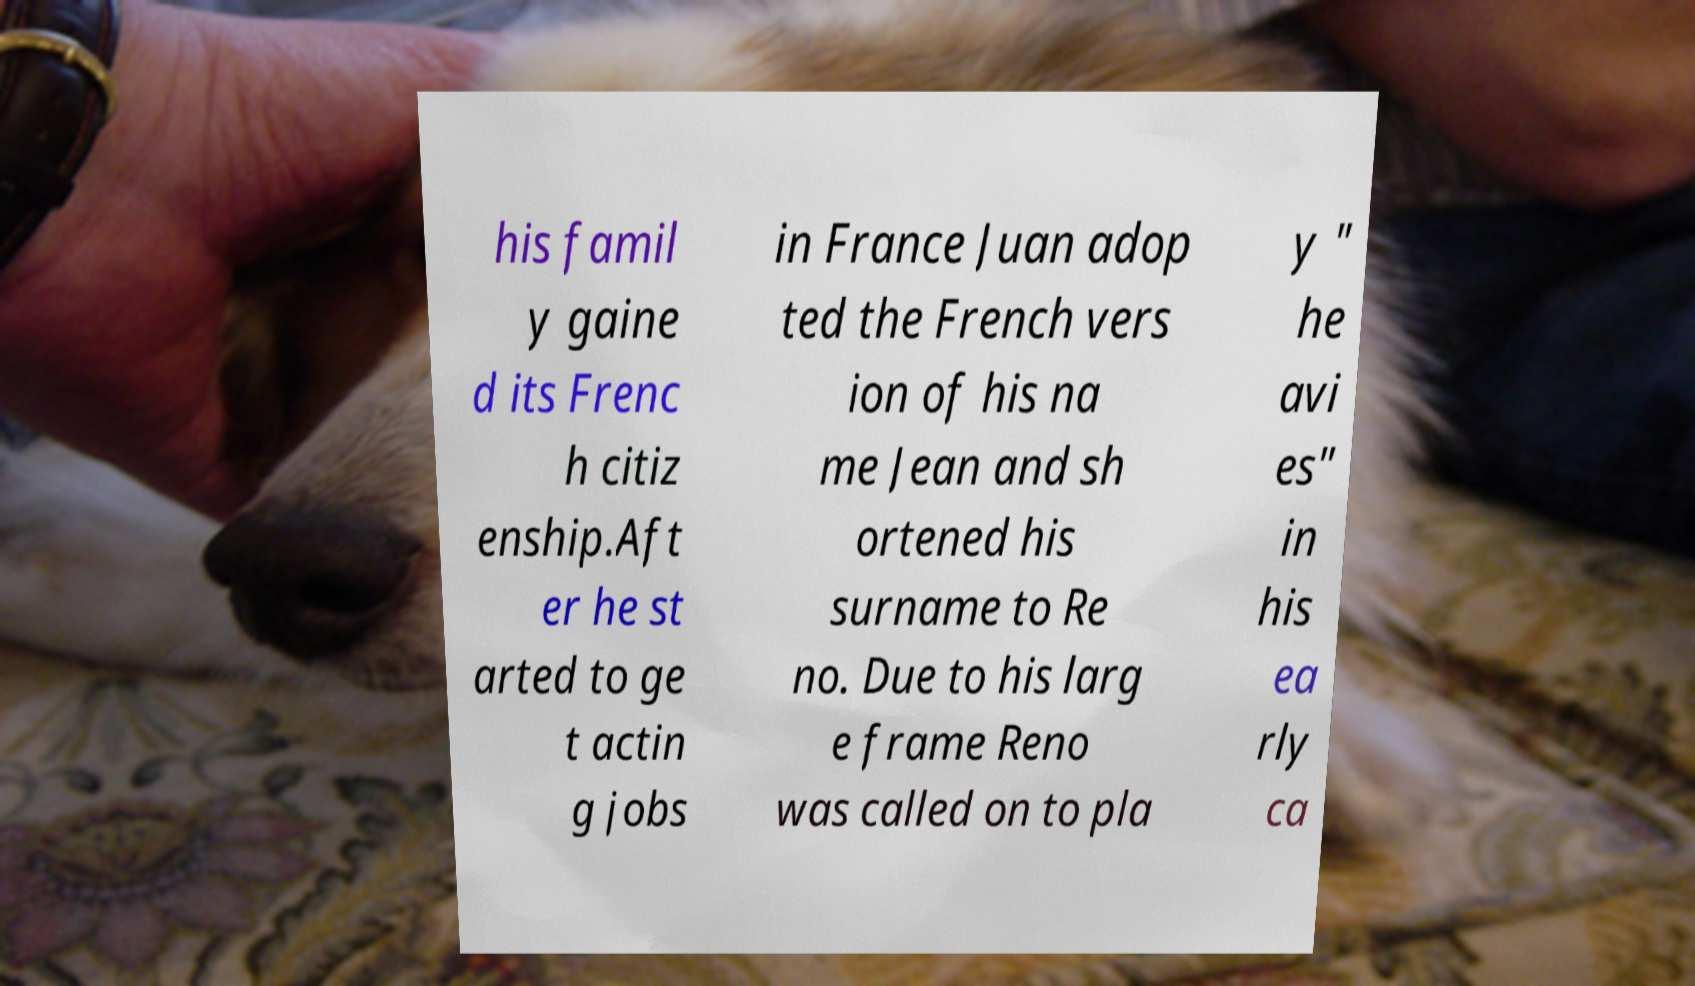Please identify and transcribe the text found in this image. his famil y gaine d its Frenc h citiz enship.Aft er he st arted to ge t actin g jobs in France Juan adop ted the French vers ion of his na me Jean and sh ortened his surname to Re no. Due to his larg e frame Reno was called on to pla y " he avi es" in his ea rly ca 